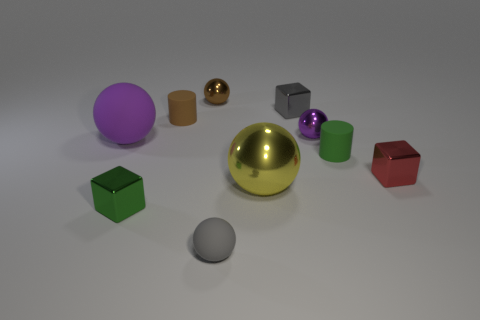Subtract all small gray rubber balls. How many balls are left? 4 Subtract all green cylinders. How many cylinders are left? 1 Subtract all purple cylinders. How many purple balls are left? 2 Subtract all cylinders. How many objects are left? 8 Subtract 3 spheres. How many spheres are left? 2 Subtract all small rubber spheres. Subtract all shiny spheres. How many objects are left? 6 Add 1 big objects. How many big objects are left? 3 Add 10 cyan matte objects. How many cyan matte objects exist? 10 Subtract 0 purple cylinders. How many objects are left? 10 Subtract all red spheres. Subtract all cyan cylinders. How many spheres are left? 5 